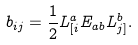Convert formula to latex. <formula><loc_0><loc_0><loc_500><loc_500>b _ { i j } = \frac { 1 } { 2 } L ^ { a } _ { [ i } E _ { a b } L ^ { b } _ { j ] } .</formula> 